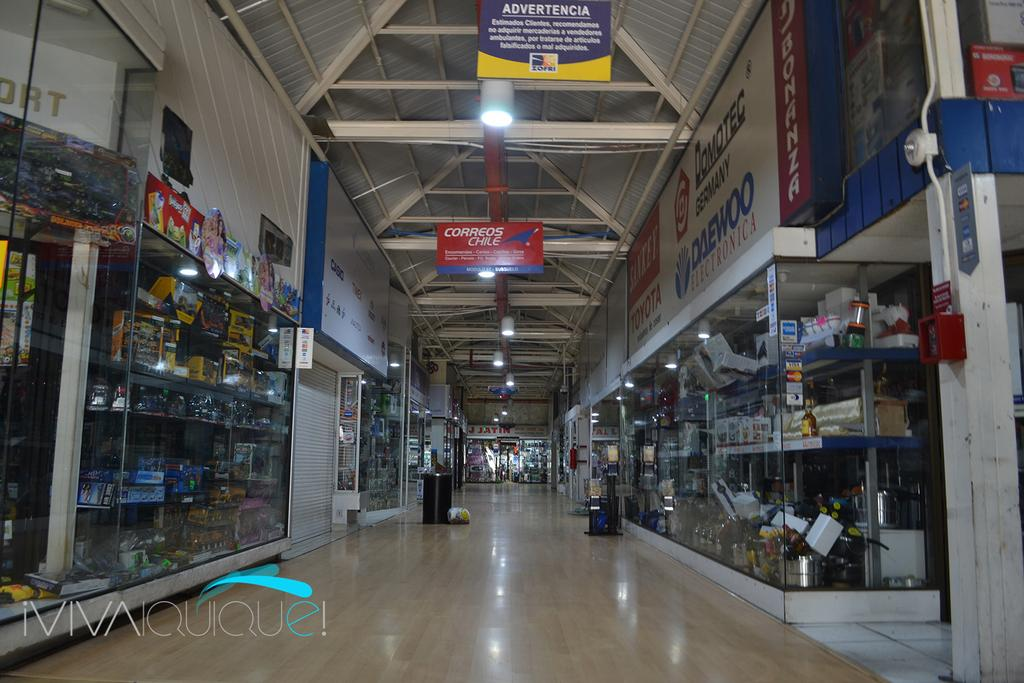<image>
Relay a brief, clear account of the picture shown. A corridor in a mall has a Correos Chile sign hanging overhead. 